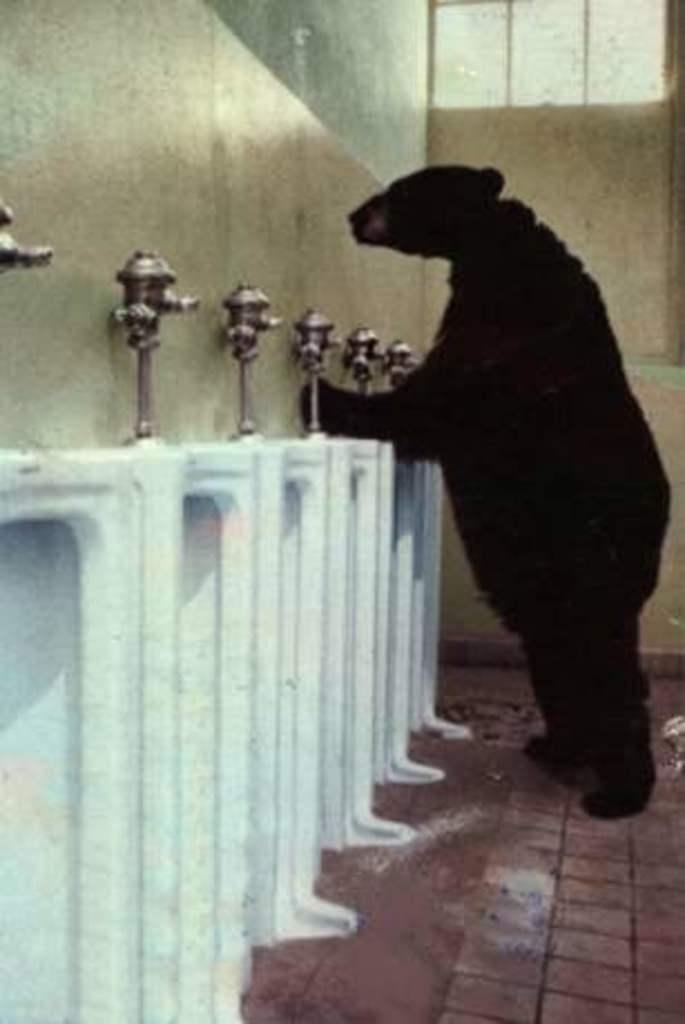Can you describe this image briefly? There is a bear which is in black color is standing in front of a white color object and there are some other objects beside it. 